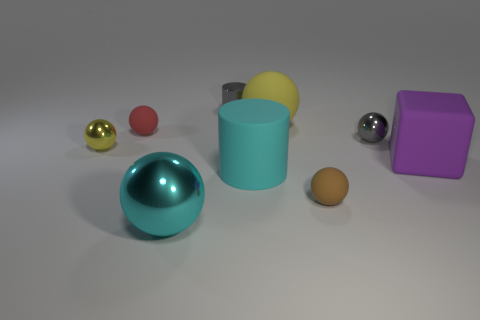Subtract all yellow spheres. How many were subtracted if there are1yellow spheres left? 1 Add 1 cyan metal objects. How many objects exist? 10 Subtract all gray metallic balls. How many balls are left? 5 Subtract 1 spheres. How many spheres are left? 5 Subtract all red blocks. Subtract all gray balls. How many blocks are left? 1 Subtract all blue cylinders. How many cyan cubes are left? 0 Subtract all big purple metal objects. Subtract all big cubes. How many objects are left? 8 Add 9 large matte balls. How many large matte balls are left? 10 Add 3 small red spheres. How many small red spheres exist? 4 Subtract all cyan spheres. How many spheres are left? 5 